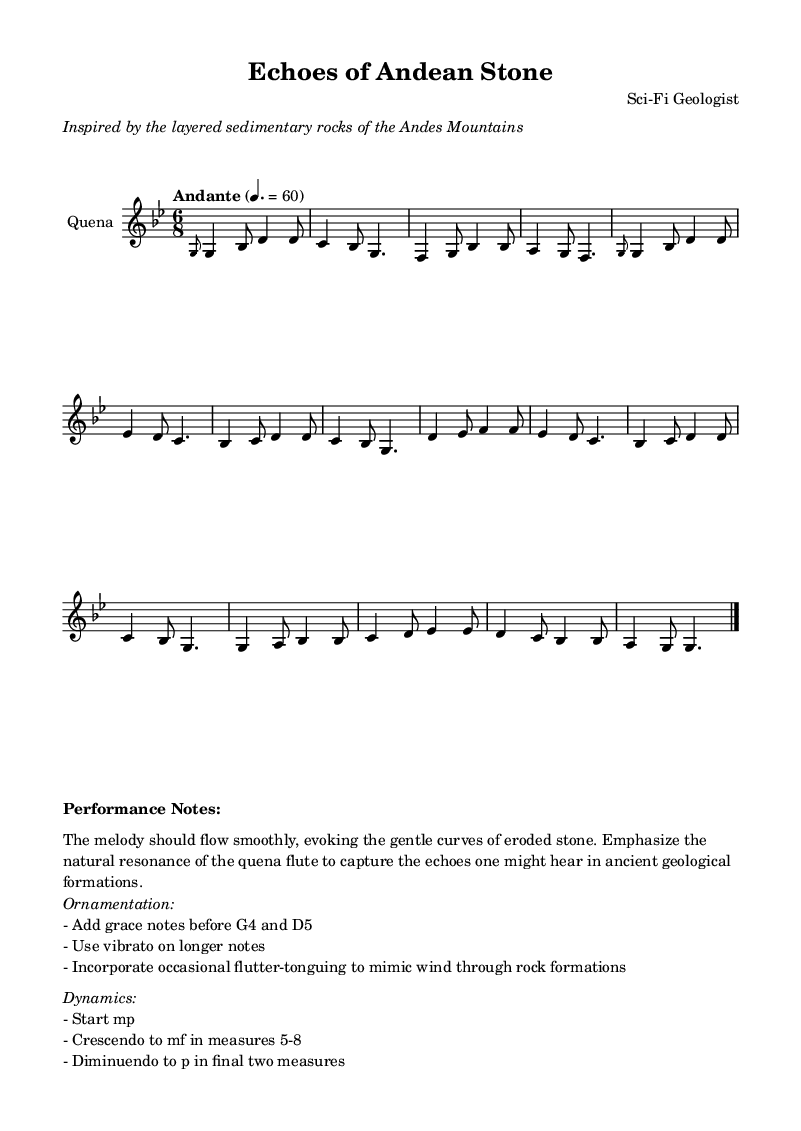What is the key signature of this music? The key signature indicated at the beginning of the music is G minor, which has two flats: B flat and E flat.
Answer: G minor What is the time signature of this music? The time signature shown at the beginning is 6/8, which means there are six eighth notes per measure.
Answer: 6/8 What tempo marking is used for this piece? The tempo marking is "Andante," which signifies a moderate pace.
Answer: Andante What instrument is specified in the score? The instrument quoted at the beginning of the score is the "Quena," a traditional Andean flute.
Answer: Quena What dynamics are suggested for the final two measures? The score directs a diminuendo to piano (p) during the final two measures, suggesting a soft ending.
Answer: piano Why is ornamentation emphasized in the performance notes? The performance notes highlight ornamentation like grace notes and vibrato to add expressiveness and mimic natural sounds, evoking the environment of ancient geological formations.
Answer: To evoke natural sounds 